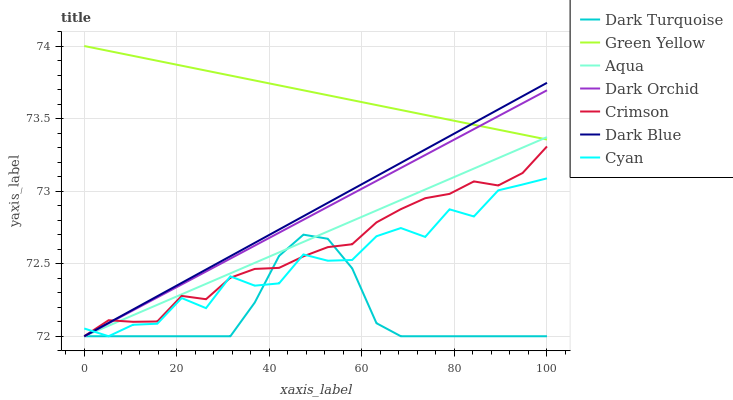Does Dark Turquoise have the minimum area under the curve?
Answer yes or no. Yes. Does Green Yellow have the maximum area under the curve?
Answer yes or no. Yes. Does Aqua have the minimum area under the curve?
Answer yes or no. No. Does Aqua have the maximum area under the curve?
Answer yes or no. No. Is Aqua the smoothest?
Answer yes or no. Yes. Is Cyan the roughest?
Answer yes or no. Yes. Is Dark Orchid the smoothest?
Answer yes or no. No. Is Dark Orchid the roughest?
Answer yes or no. No. Does Dark Turquoise have the lowest value?
Answer yes or no. Yes. Does Green Yellow have the lowest value?
Answer yes or no. No. Does Green Yellow have the highest value?
Answer yes or no. Yes. Does Aqua have the highest value?
Answer yes or no. No. Is Cyan less than Green Yellow?
Answer yes or no. Yes. Is Green Yellow greater than Crimson?
Answer yes or no. Yes. Does Dark Blue intersect Dark Turquoise?
Answer yes or no. Yes. Is Dark Blue less than Dark Turquoise?
Answer yes or no. No. Is Dark Blue greater than Dark Turquoise?
Answer yes or no. No. Does Cyan intersect Green Yellow?
Answer yes or no. No. 